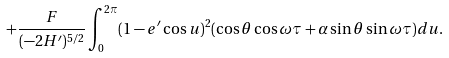Convert formula to latex. <formula><loc_0><loc_0><loc_500><loc_500>+ \frac { F } { ( - 2 H ^ { \prime } ) ^ { 5 / 2 } } \int _ { 0 } ^ { 2 \pi } ( 1 - e ^ { \prime } \cos u ) ^ { 2 } ( \cos \theta \cos \omega \tau + \alpha \sin \theta \sin \omega \tau ) d u .</formula> 